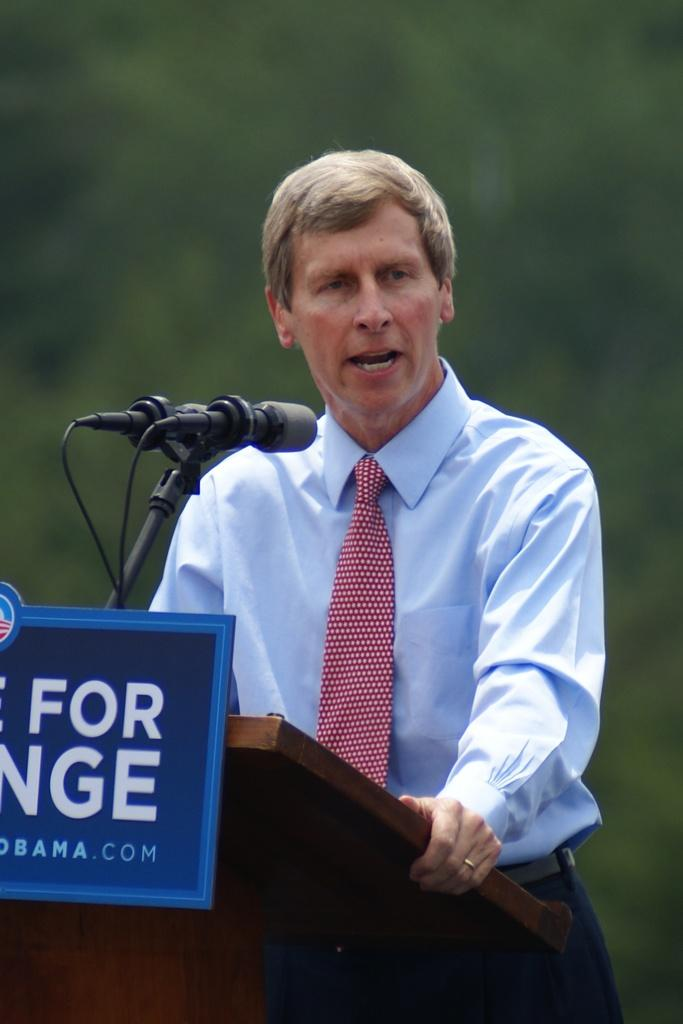Who is the main subject in the image? There is a man in the image. What is the man wearing around his neck? The man is wearing a tie. What is the man doing at the podium? The man is standing at a podium and talking on a microphone. Can you describe the background of the image? The background of the image is blurry. What type of rock can be seen in the background of the image? There is no rock present in the background of the image; it is blurry and does not show any specific objects or features. 